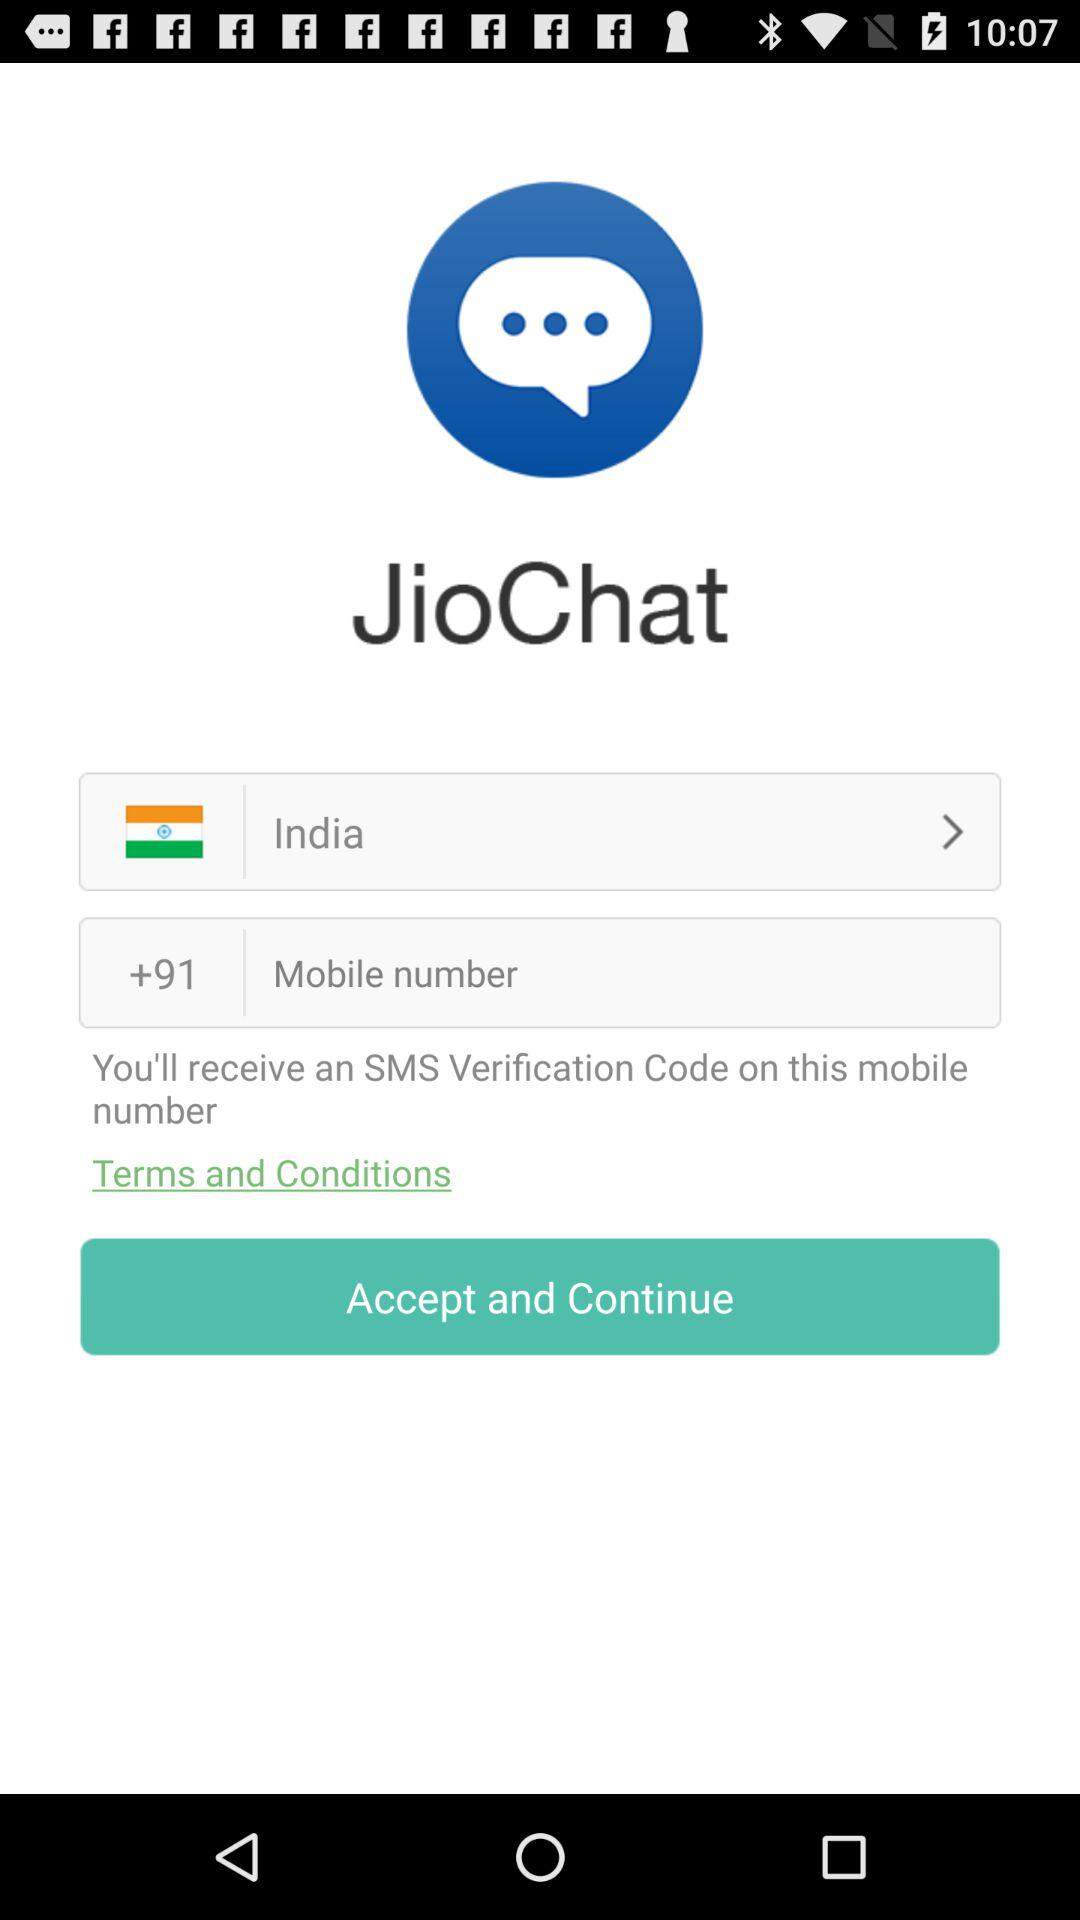What is the name of the application? The application is "JioChat". 